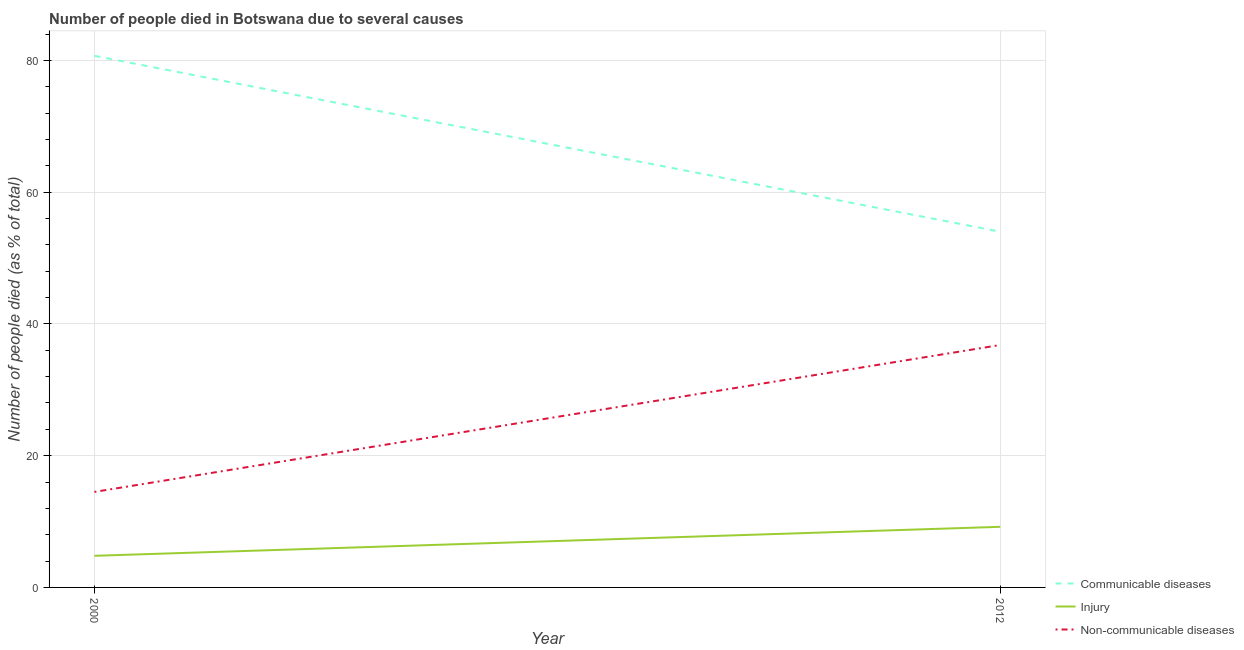How many different coloured lines are there?
Your response must be concise. 3. Is the number of lines equal to the number of legend labels?
Make the answer very short. Yes. What is the number of people who dies of non-communicable diseases in 2012?
Make the answer very short. 36.8. Across all years, what is the maximum number of people who dies of non-communicable diseases?
Your answer should be compact. 36.8. In which year was the number of people who died of injury maximum?
Your response must be concise. 2012. What is the total number of people who died of communicable diseases in the graph?
Make the answer very short. 134.7. What is the difference between the number of people who dies of non-communicable diseases in 2000 and that in 2012?
Your response must be concise. -22.3. What is the difference between the number of people who died of communicable diseases in 2012 and the number of people who dies of non-communicable diseases in 2000?
Give a very brief answer. 39.5. What is the average number of people who died of injury per year?
Give a very brief answer. 7. In the year 2012, what is the difference between the number of people who dies of non-communicable diseases and number of people who died of injury?
Your answer should be compact. 27.6. In how many years, is the number of people who dies of non-communicable diseases greater than 72 %?
Make the answer very short. 0. What is the ratio of the number of people who dies of non-communicable diseases in 2000 to that in 2012?
Give a very brief answer. 0.39. In how many years, is the number of people who died of injury greater than the average number of people who died of injury taken over all years?
Your answer should be very brief. 1. Is the number of people who died of injury strictly less than the number of people who dies of non-communicable diseases over the years?
Your response must be concise. Yes. What is the difference between two consecutive major ticks on the Y-axis?
Keep it short and to the point. 20. Are the values on the major ticks of Y-axis written in scientific E-notation?
Give a very brief answer. No. Does the graph contain any zero values?
Your response must be concise. No. Does the graph contain grids?
Ensure brevity in your answer.  Yes. Where does the legend appear in the graph?
Make the answer very short. Bottom right. How many legend labels are there?
Offer a terse response. 3. What is the title of the graph?
Your response must be concise. Number of people died in Botswana due to several causes. Does "Other sectors" appear as one of the legend labels in the graph?
Your answer should be very brief. No. What is the label or title of the X-axis?
Make the answer very short. Year. What is the label or title of the Y-axis?
Offer a terse response. Number of people died (as % of total). What is the Number of people died (as % of total) of Communicable diseases in 2000?
Offer a terse response. 80.7. What is the Number of people died (as % of total) of Injury in 2000?
Ensure brevity in your answer.  4.8. What is the Number of people died (as % of total) of Injury in 2012?
Provide a succinct answer. 9.2. What is the Number of people died (as % of total) in Non-communicable diseases in 2012?
Your response must be concise. 36.8. Across all years, what is the maximum Number of people died (as % of total) in Communicable diseases?
Give a very brief answer. 80.7. Across all years, what is the maximum Number of people died (as % of total) of Injury?
Give a very brief answer. 9.2. Across all years, what is the maximum Number of people died (as % of total) of Non-communicable diseases?
Provide a succinct answer. 36.8. Across all years, what is the minimum Number of people died (as % of total) of Non-communicable diseases?
Ensure brevity in your answer.  14.5. What is the total Number of people died (as % of total) in Communicable diseases in the graph?
Provide a short and direct response. 134.7. What is the total Number of people died (as % of total) of Injury in the graph?
Offer a terse response. 14. What is the total Number of people died (as % of total) of Non-communicable diseases in the graph?
Keep it short and to the point. 51.3. What is the difference between the Number of people died (as % of total) in Communicable diseases in 2000 and that in 2012?
Offer a very short reply. 26.7. What is the difference between the Number of people died (as % of total) in Non-communicable diseases in 2000 and that in 2012?
Your response must be concise. -22.3. What is the difference between the Number of people died (as % of total) in Communicable diseases in 2000 and the Number of people died (as % of total) in Injury in 2012?
Ensure brevity in your answer.  71.5. What is the difference between the Number of people died (as % of total) of Communicable diseases in 2000 and the Number of people died (as % of total) of Non-communicable diseases in 2012?
Offer a terse response. 43.9. What is the difference between the Number of people died (as % of total) in Injury in 2000 and the Number of people died (as % of total) in Non-communicable diseases in 2012?
Keep it short and to the point. -32. What is the average Number of people died (as % of total) of Communicable diseases per year?
Ensure brevity in your answer.  67.35. What is the average Number of people died (as % of total) of Injury per year?
Offer a very short reply. 7. What is the average Number of people died (as % of total) in Non-communicable diseases per year?
Provide a succinct answer. 25.65. In the year 2000, what is the difference between the Number of people died (as % of total) of Communicable diseases and Number of people died (as % of total) of Injury?
Your answer should be very brief. 75.9. In the year 2000, what is the difference between the Number of people died (as % of total) in Communicable diseases and Number of people died (as % of total) in Non-communicable diseases?
Offer a very short reply. 66.2. In the year 2000, what is the difference between the Number of people died (as % of total) of Injury and Number of people died (as % of total) of Non-communicable diseases?
Offer a terse response. -9.7. In the year 2012, what is the difference between the Number of people died (as % of total) in Communicable diseases and Number of people died (as % of total) in Injury?
Ensure brevity in your answer.  44.8. In the year 2012, what is the difference between the Number of people died (as % of total) of Communicable diseases and Number of people died (as % of total) of Non-communicable diseases?
Give a very brief answer. 17.2. In the year 2012, what is the difference between the Number of people died (as % of total) of Injury and Number of people died (as % of total) of Non-communicable diseases?
Your answer should be compact. -27.6. What is the ratio of the Number of people died (as % of total) of Communicable diseases in 2000 to that in 2012?
Your answer should be very brief. 1.49. What is the ratio of the Number of people died (as % of total) in Injury in 2000 to that in 2012?
Provide a short and direct response. 0.52. What is the ratio of the Number of people died (as % of total) of Non-communicable diseases in 2000 to that in 2012?
Your response must be concise. 0.39. What is the difference between the highest and the second highest Number of people died (as % of total) in Communicable diseases?
Make the answer very short. 26.7. What is the difference between the highest and the second highest Number of people died (as % of total) in Injury?
Ensure brevity in your answer.  4.4. What is the difference between the highest and the second highest Number of people died (as % of total) in Non-communicable diseases?
Your response must be concise. 22.3. What is the difference between the highest and the lowest Number of people died (as % of total) of Communicable diseases?
Provide a succinct answer. 26.7. What is the difference between the highest and the lowest Number of people died (as % of total) of Injury?
Offer a very short reply. 4.4. What is the difference between the highest and the lowest Number of people died (as % of total) of Non-communicable diseases?
Offer a very short reply. 22.3. 